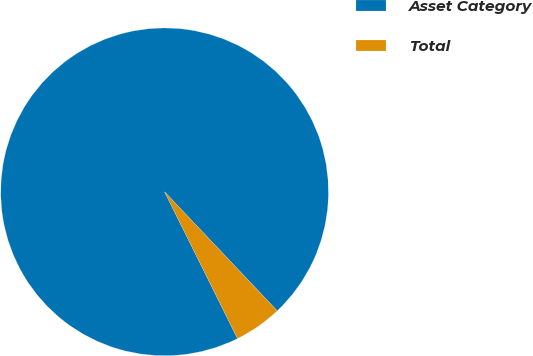Convert chart to OTSL. <chart><loc_0><loc_0><loc_500><loc_500><pie_chart><fcel>Asset Category<fcel>Total<nl><fcel>95.28%<fcel>4.72%<nl></chart> 